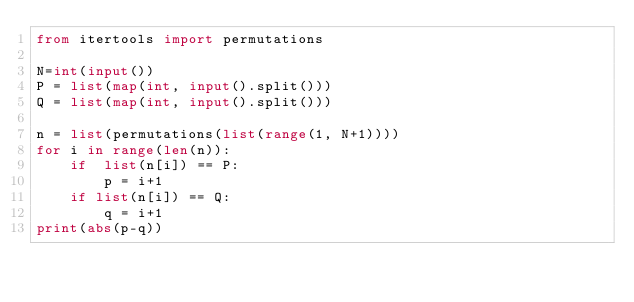Convert code to text. <code><loc_0><loc_0><loc_500><loc_500><_Python_>from itertools import permutations

N=int(input())
P = list(map(int, input().split()))
Q = list(map(int, input().split()))

n = list(permutations(list(range(1, N+1))))
for i in range(len(n)):
    if  list(n[i]) == P:
        p = i+1
    if list(n[i]) == Q:
        q = i+1
print(abs(p-q))</code> 